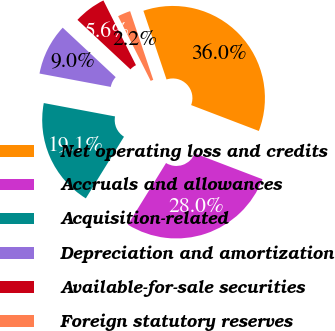<chart> <loc_0><loc_0><loc_500><loc_500><pie_chart><fcel>Net operating loss and credits<fcel>Accruals and allowances<fcel>Acquisition-related<fcel>Depreciation and amortization<fcel>Available-for-sale securities<fcel>Foreign statutory reserves<nl><fcel>35.98%<fcel>28.01%<fcel>19.13%<fcel>9.0%<fcel>5.63%<fcel>2.25%<nl></chart> 